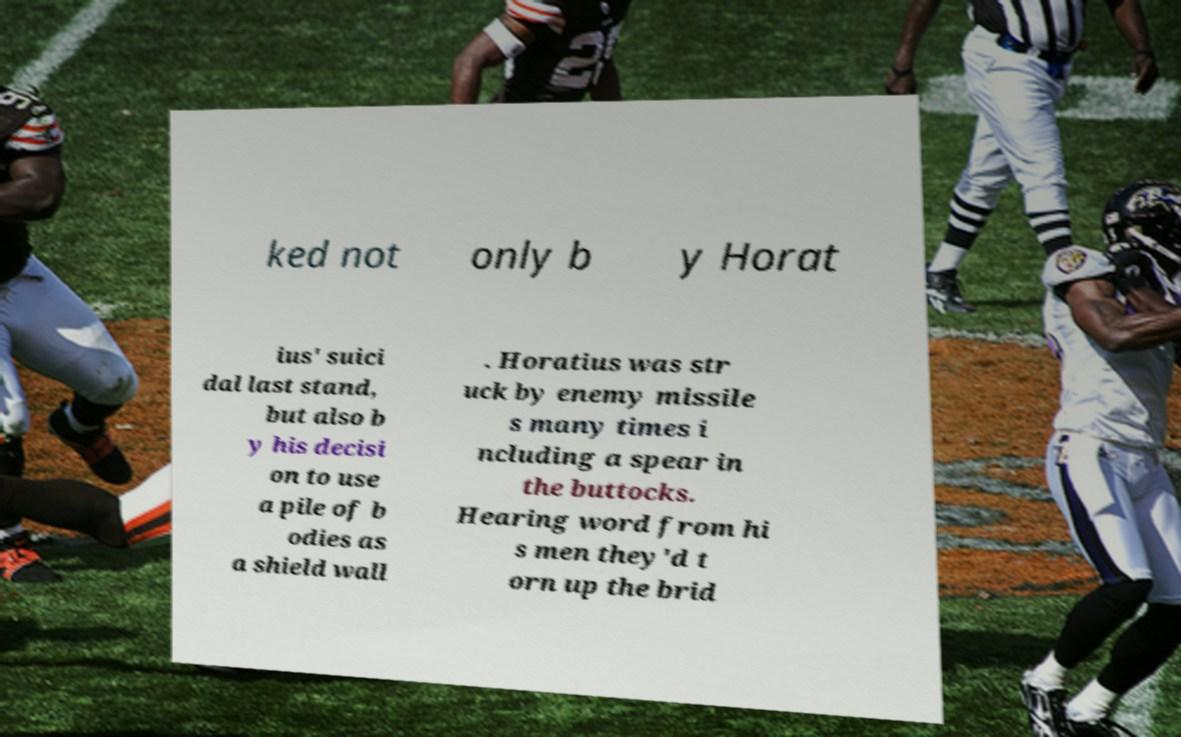I need the written content from this picture converted into text. Can you do that? ked not only b y Horat ius' suici dal last stand, but also b y his decisi on to use a pile of b odies as a shield wall . Horatius was str uck by enemy missile s many times i ncluding a spear in the buttocks. Hearing word from hi s men they'd t orn up the brid 